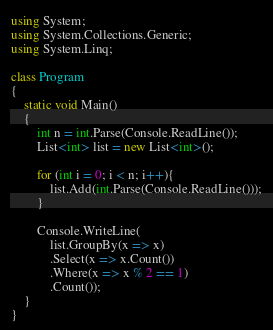Convert code to text. <code><loc_0><loc_0><loc_500><loc_500><_C#_>using System;
using System.Collections.Generic;
using System.Linq;

class Program
{
    static void Main()
    {
        int n = int.Parse(Console.ReadLine());
        List<int> list = new List<int>();
        
        for (int i = 0; i < n; i++){
            list.Add(int.Parse(Console.ReadLine()));
        }

        Console.WriteLine(
            list.GroupBy(x => x)
            .Select(x => x.Count())
            .Where(x => x % 2 == 1)
            .Count());
    }
}
</code> 